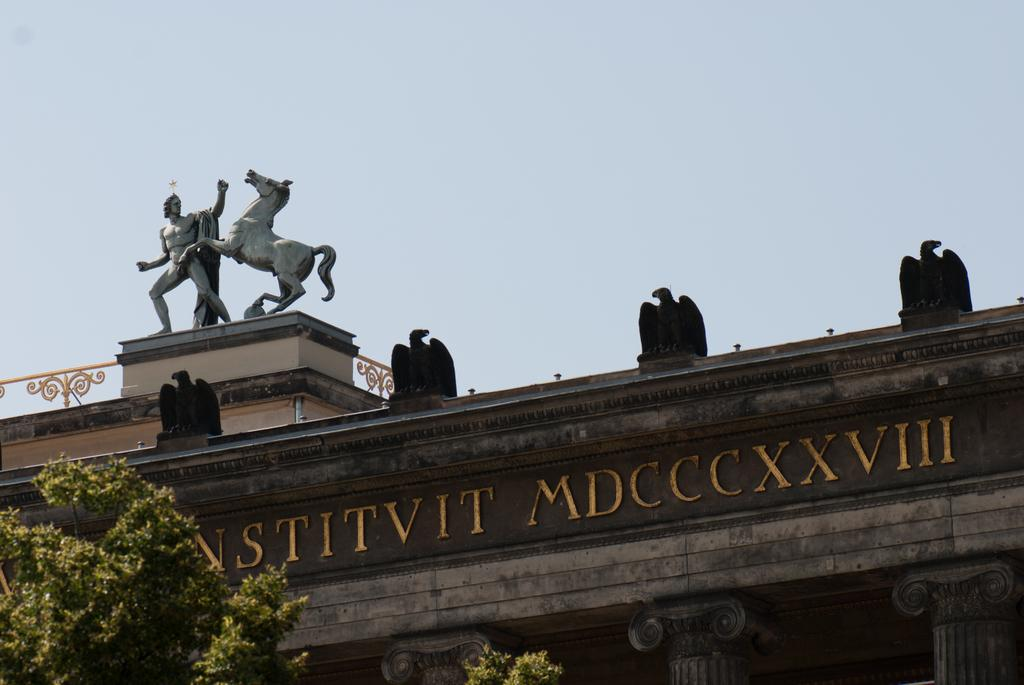What is located on top of the building in the image? There is a statue on a building in the image. What can be seen near the building in the image? There is a sign board and trees visible in the image. What architectural features are present in the image? There are pillars in the image. What is visible in the sky in the image? The sky is visible in the image and appears cloudy. How many tickets are required to cross the bridge in the image? There is no bridge present in the image, so the question about tickets is not applicable. 